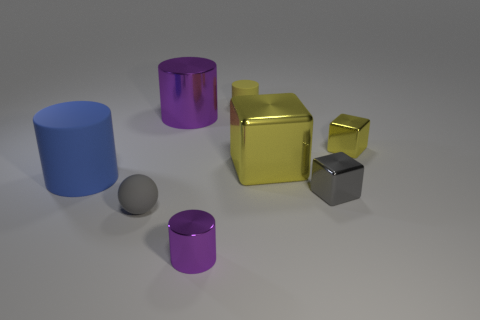Add 1 large shiny cubes. How many objects exist? 9 Subtract all balls. How many objects are left? 7 Add 2 big yellow metal cylinders. How many big yellow metal cylinders exist? 2 Subtract 0 gray cylinders. How many objects are left? 8 Subtract all large metal blocks. Subtract all small gray rubber balls. How many objects are left? 6 Add 5 tiny purple shiny cylinders. How many tiny purple shiny cylinders are left? 6 